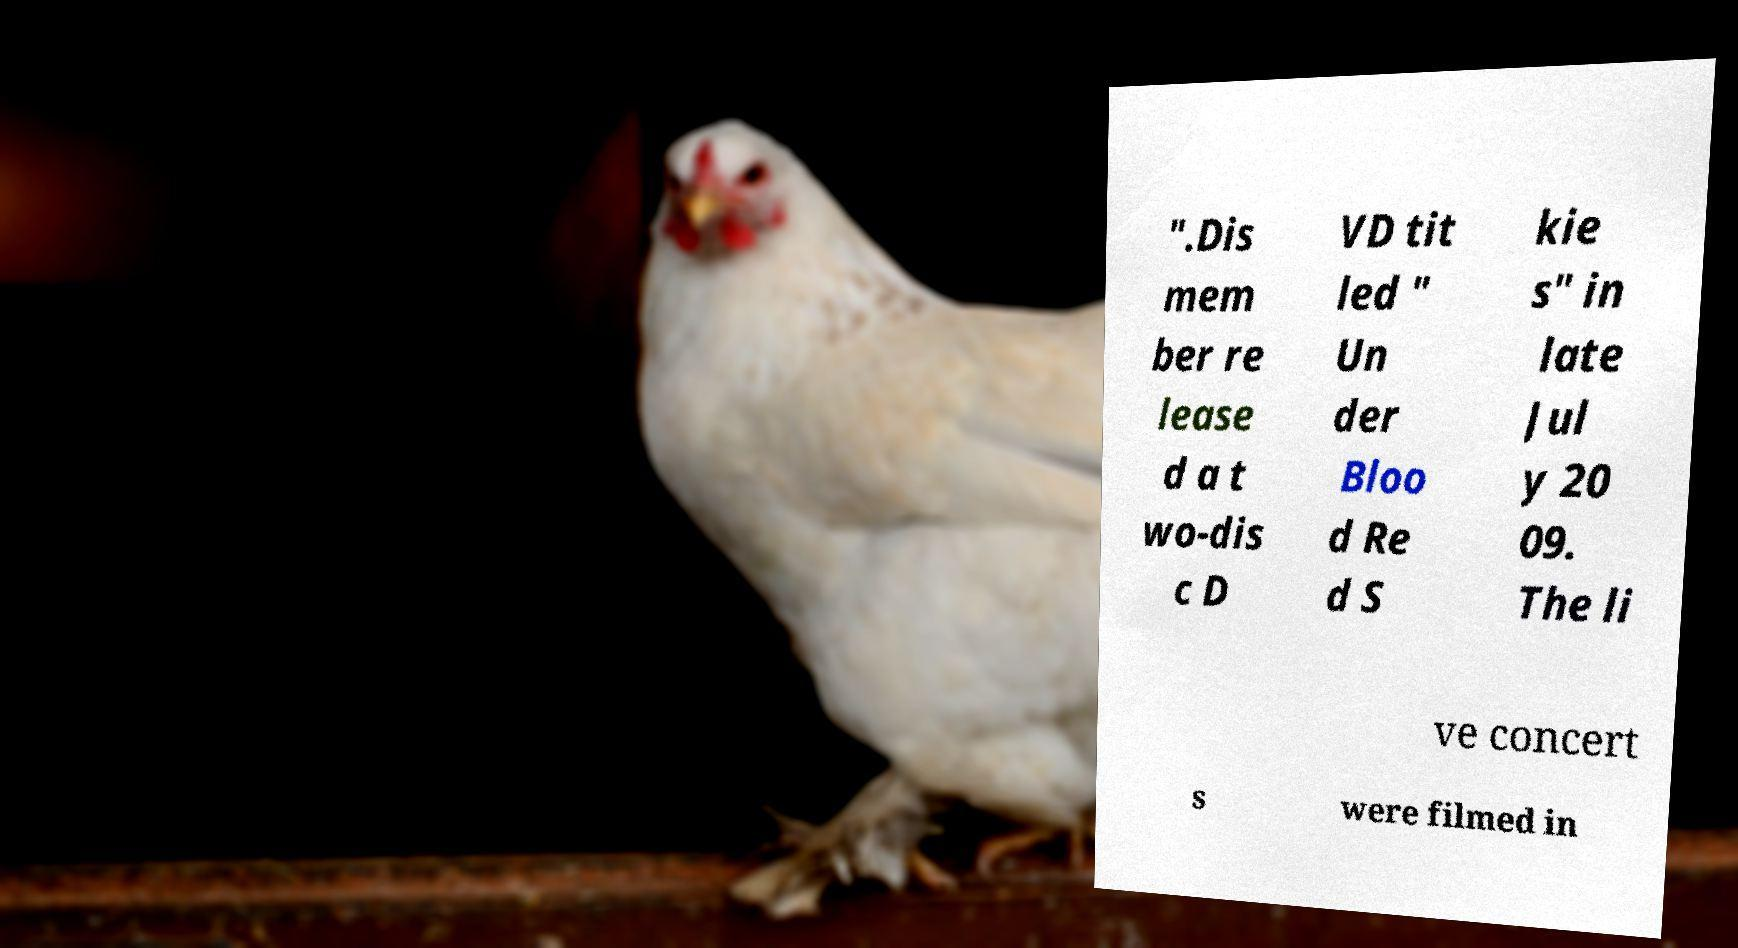What messages or text are displayed in this image? I need them in a readable, typed format. ".Dis mem ber re lease d a t wo-dis c D VD tit led " Un der Bloo d Re d S kie s" in late Jul y 20 09. The li ve concert s were filmed in 